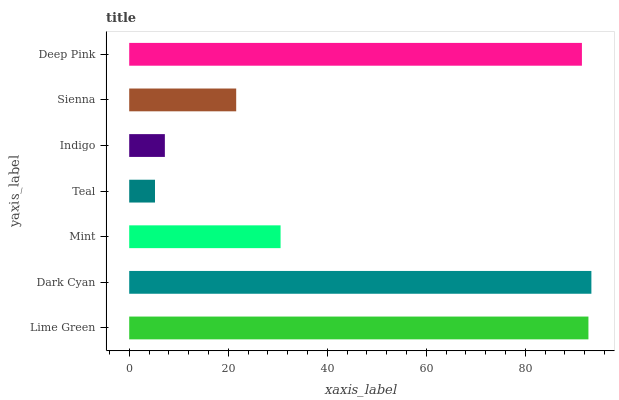Is Teal the minimum?
Answer yes or no. Yes. Is Dark Cyan the maximum?
Answer yes or no. Yes. Is Mint the minimum?
Answer yes or no. No. Is Mint the maximum?
Answer yes or no. No. Is Dark Cyan greater than Mint?
Answer yes or no. Yes. Is Mint less than Dark Cyan?
Answer yes or no. Yes. Is Mint greater than Dark Cyan?
Answer yes or no. No. Is Dark Cyan less than Mint?
Answer yes or no. No. Is Mint the high median?
Answer yes or no. Yes. Is Mint the low median?
Answer yes or no. Yes. Is Sienna the high median?
Answer yes or no. No. Is Sienna the low median?
Answer yes or no. No. 